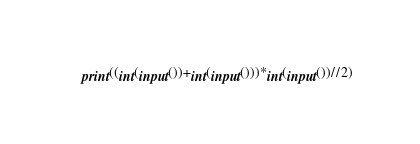<code> <loc_0><loc_0><loc_500><loc_500><_Python_>print((int(input())+int(input()))*int(input())//2)</code> 